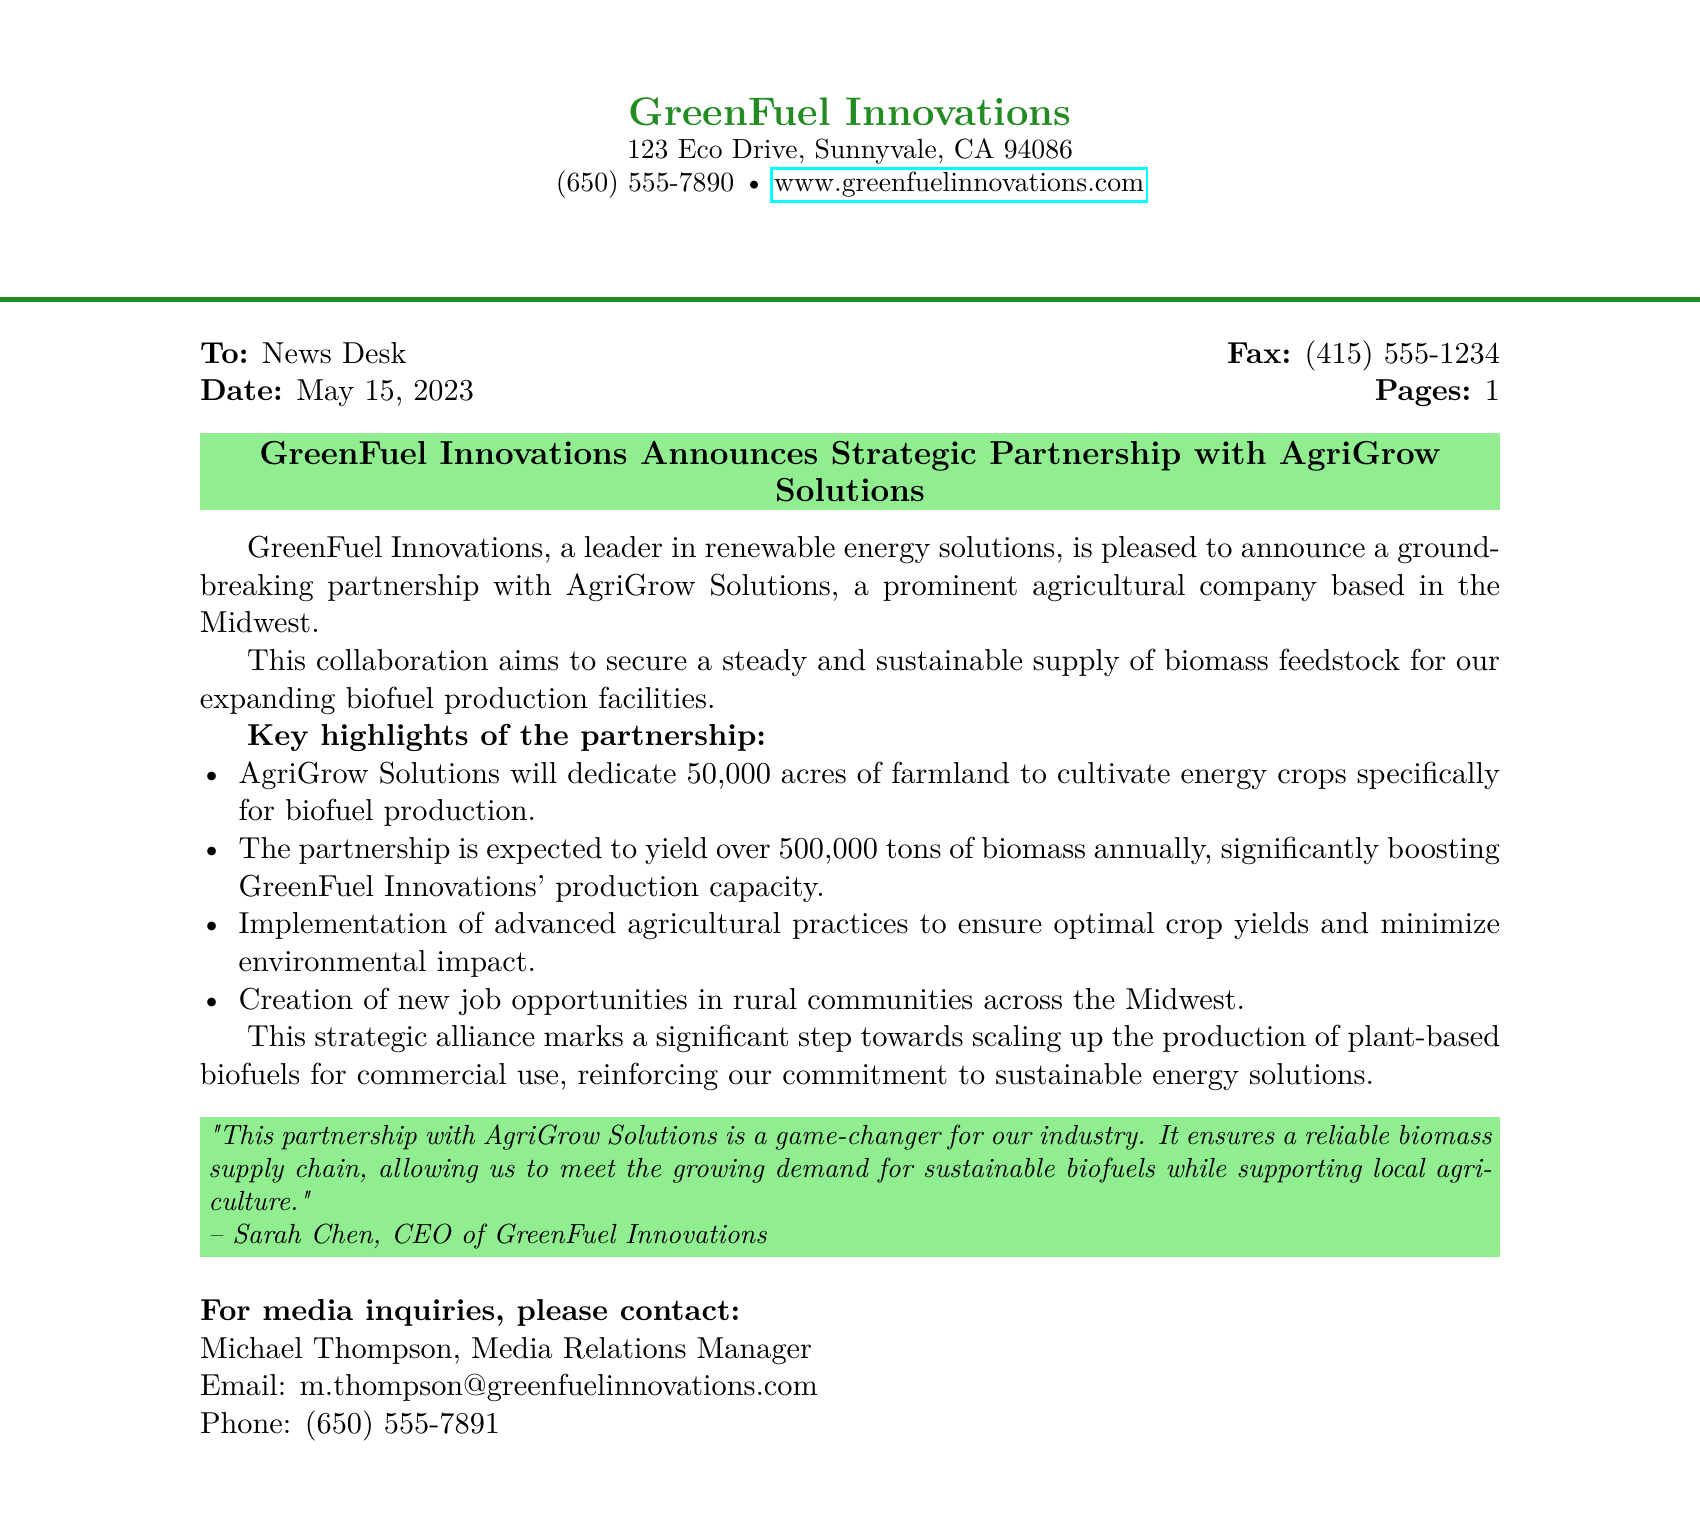What is the name of the partnership? The document states the partnership is between GreenFuel Innovations and AgriGrow Solutions.
Answer: AgriGrow Solutions How many acres will AgriGrow Solutions dedicate for energy crops? The document specifies that AgriGrow Solutions will dedicate 50,000 acres for cultivation.
Answer: 50,000 acres What is the expected annual yield of biomass from this partnership? The document mentions an expected yield of over 500,000 tons of biomass annually.
Answer: Over 500,000 tons Who is the CEO of GreenFuel Innovations? The document quotes Sarah Chen as the CEO of GreenFuel Innovations.
Answer: Sarah Chen What impact will the partnership have on job opportunities? It states that the partnership will create new job opportunities in rural communities.
Answer: New job opportunities What is the publication date of the press release? The document indicates the press release was dated May 15, 2023.
Answer: May 15, 2023 What advanced practices will be implemented according to the partnership? The document notes the implementation of advanced agricultural practices for optimal crop yields.
Answer: Advanced agricultural practices What is the primary goal of the partnership according to the document? The document states the partnership aims to secure a steady and sustainable supply of biomass feedstock.
Answer: Secure a steady and sustainable supply of biomass feedstock 